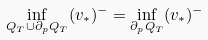<formula> <loc_0><loc_0><loc_500><loc_500>\inf _ { Q _ { T } \cup \partial _ { p } Q _ { T } } ( v _ { * } ) ^ { - } = \inf _ { \partial _ { p } Q _ { T } } ( v _ { * } ) ^ { - } \quad</formula> 